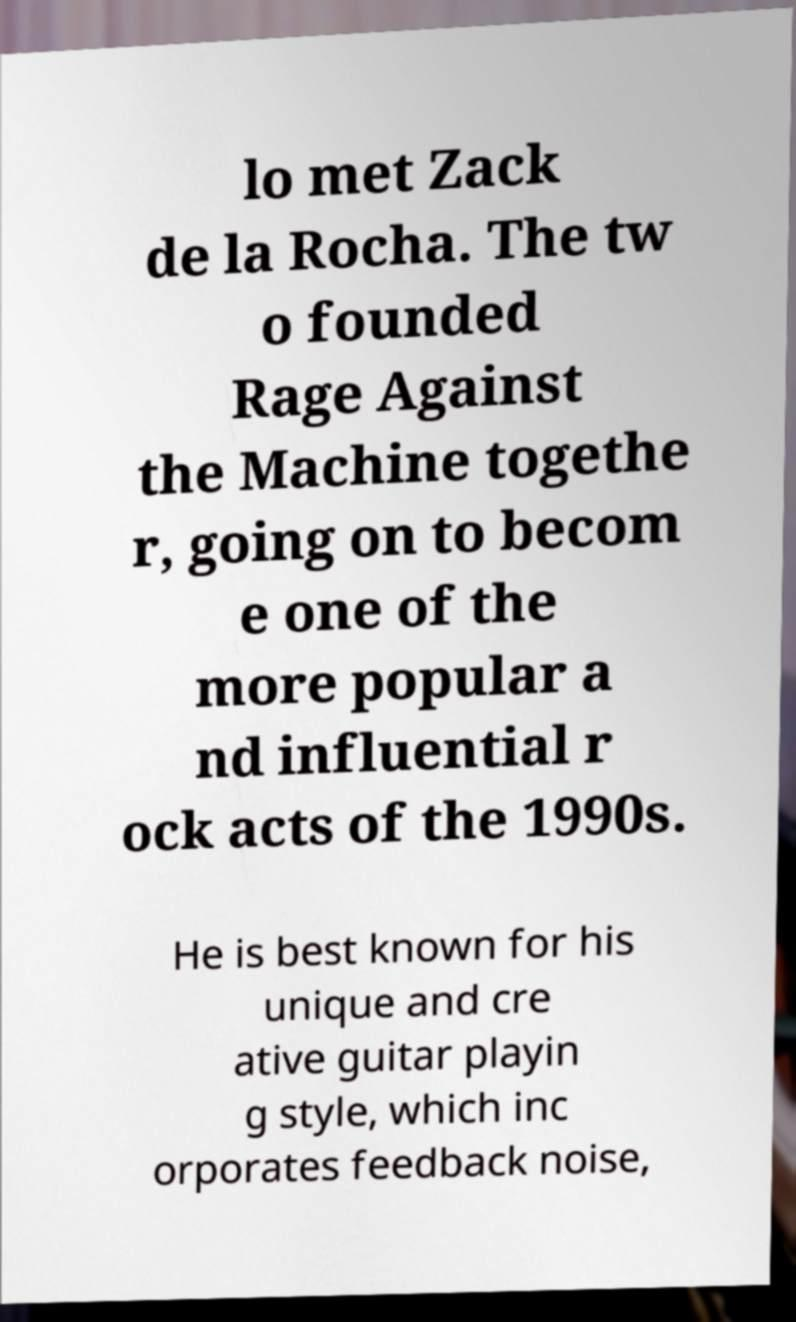There's text embedded in this image that I need extracted. Can you transcribe it verbatim? lo met Zack de la Rocha. The tw o founded Rage Against the Machine togethe r, going on to becom e one of the more popular a nd influential r ock acts of the 1990s. He is best known for his unique and cre ative guitar playin g style, which inc orporates feedback noise, 